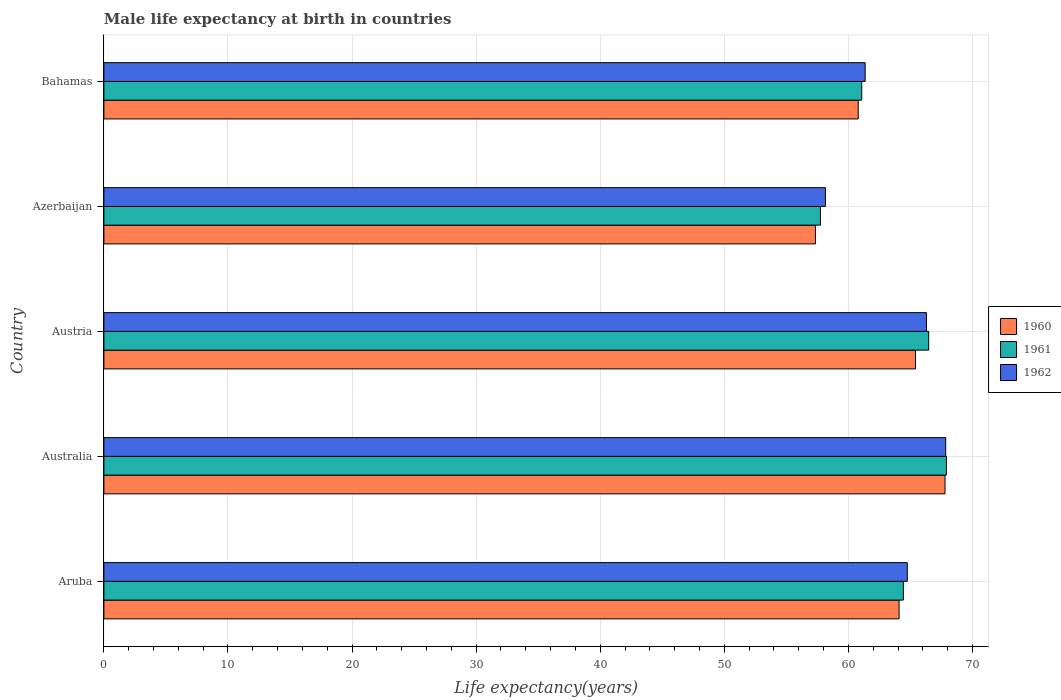How many different coloured bars are there?
Make the answer very short. 3. Are the number of bars on each tick of the Y-axis equal?
Provide a succinct answer. Yes. How many bars are there on the 2nd tick from the top?
Your response must be concise. 3. How many bars are there on the 3rd tick from the bottom?
Provide a succinct answer. 3. What is the label of the 1st group of bars from the top?
Make the answer very short. Bahamas. What is the male life expectancy at birth in 1962 in Australia?
Give a very brief answer. 67.84. Across all countries, what is the maximum male life expectancy at birth in 1961?
Provide a short and direct response. 67.9. Across all countries, what is the minimum male life expectancy at birth in 1962?
Keep it short and to the point. 58.15. In which country was the male life expectancy at birth in 1960 maximum?
Provide a succinct answer. Australia. In which country was the male life expectancy at birth in 1960 minimum?
Provide a short and direct response. Azerbaijan. What is the total male life expectancy at birth in 1962 in the graph?
Your response must be concise. 318.37. What is the difference between the male life expectancy at birth in 1962 in Australia and that in Azerbaijan?
Keep it short and to the point. 9.69. What is the difference between the male life expectancy at birth in 1962 in Bahamas and the male life expectancy at birth in 1960 in Aruba?
Ensure brevity in your answer.  -2.74. What is the average male life expectancy at birth in 1962 per country?
Offer a very short reply. 63.67. What is the difference between the male life expectancy at birth in 1962 and male life expectancy at birth in 1961 in Azerbaijan?
Provide a short and direct response. 0.4. In how many countries, is the male life expectancy at birth in 1962 greater than 62 years?
Your response must be concise. 3. What is the ratio of the male life expectancy at birth in 1962 in Australia to that in Bahamas?
Provide a short and direct response. 1.11. What is the difference between the highest and the second highest male life expectancy at birth in 1961?
Provide a succinct answer. 1.43. What is the difference between the highest and the lowest male life expectancy at birth in 1960?
Offer a terse response. 10.44. In how many countries, is the male life expectancy at birth in 1960 greater than the average male life expectancy at birth in 1960 taken over all countries?
Keep it short and to the point. 3. What does the 3rd bar from the bottom in Bahamas represents?
Give a very brief answer. 1962. Is it the case that in every country, the sum of the male life expectancy at birth in 1962 and male life expectancy at birth in 1961 is greater than the male life expectancy at birth in 1960?
Your answer should be very brief. Yes. How many bars are there?
Your response must be concise. 15. How many countries are there in the graph?
Your answer should be very brief. 5. What is the difference between two consecutive major ticks on the X-axis?
Make the answer very short. 10. Does the graph contain grids?
Ensure brevity in your answer.  Yes. How are the legend labels stacked?
Ensure brevity in your answer.  Vertical. What is the title of the graph?
Make the answer very short. Male life expectancy at birth in countries. Does "1990" appear as one of the legend labels in the graph?
Provide a short and direct response. No. What is the label or title of the X-axis?
Offer a terse response. Life expectancy(years). What is the Life expectancy(years) in 1960 in Aruba?
Make the answer very short. 64.08. What is the Life expectancy(years) in 1961 in Aruba?
Offer a terse response. 64.43. What is the Life expectancy(years) of 1962 in Aruba?
Offer a terse response. 64.75. What is the Life expectancy(years) of 1960 in Australia?
Keep it short and to the point. 67.79. What is the Life expectancy(years) in 1961 in Australia?
Provide a succinct answer. 67.9. What is the Life expectancy(years) of 1962 in Australia?
Provide a succinct answer. 67.84. What is the Life expectancy(years) of 1960 in Austria?
Your response must be concise. 65.41. What is the Life expectancy(years) in 1961 in Austria?
Your response must be concise. 66.47. What is the Life expectancy(years) in 1962 in Austria?
Your answer should be compact. 66.29. What is the Life expectancy(years) in 1960 in Azerbaijan?
Provide a succinct answer. 57.35. What is the Life expectancy(years) of 1961 in Azerbaijan?
Make the answer very short. 57.75. What is the Life expectancy(years) in 1962 in Azerbaijan?
Provide a succinct answer. 58.15. What is the Life expectancy(years) of 1960 in Bahamas?
Ensure brevity in your answer.  60.79. What is the Life expectancy(years) of 1961 in Bahamas?
Provide a succinct answer. 61.07. What is the Life expectancy(years) in 1962 in Bahamas?
Offer a very short reply. 61.35. Across all countries, what is the maximum Life expectancy(years) in 1960?
Offer a terse response. 67.79. Across all countries, what is the maximum Life expectancy(years) in 1961?
Your response must be concise. 67.9. Across all countries, what is the maximum Life expectancy(years) of 1962?
Your answer should be compact. 67.84. Across all countries, what is the minimum Life expectancy(years) of 1960?
Offer a very short reply. 57.35. Across all countries, what is the minimum Life expectancy(years) in 1961?
Provide a succinct answer. 57.75. Across all countries, what is the minimum Life expectancy(years) of 1962?
Give a very brief answer. 58.15. What is the total Life expectancy(years) of 1960 in the graph?
Your answer should be compact. 315.42. What is the total Life expectancy(years) of 1961 in the graph?
Your answer should be very brief. 317.62. What is the total Life expectancy(years) in 1962 in the graph?
Offer a very short reply. 318.37. What is the difference between the Life expectancy(years) in 1960 in Aruba and that in Australia?
Give a very brief answer. -3.7. What is the difference between the Life expectancy(years) in 1961 in Aruba and that in Australia?
Your response must be concise. -3.47. What is the difference between the Life expectancy(years) in 1962 in Aruba and that in Australia?
Your answer should be compact. -3.09. What is the difference between the Life expectancy(years) in 1960 in Aruba and that in Austria?
Your response must be concise. -1.33. What is the difference between the Life expectancy(years) of 1961 in Aruba and that in Austria?
Provide a succinct answer. -2.04. What is the difference between the Life expectancy(years) in 1962 in Aruba and that in Austria?
Give a very brief answer. -1.54. What is the difference between the Life expectancy(years) in 1960 in Aruba and that in Azerbaijan?
Provide a succinct answer. 6.74. What is the difference between the Life expectancy(years) in 1961 in Aruba and that in Azerbaijan?
Offer a very short reply. 6.68. What is the difference between the Life expectancy(years) of 1962 in Aruba and that in Azerbaijan?
Make the answer very short. 6.6. What is the difference between the Life expectancy(years) of 1960 in Aruba and that in Bahamas?
Ensure brevity in your answer.  3.29. What is the difference between the Life expectancy(years) in 1961 in Aruba and that in Bahamas?
Ensure brevity in your answer.  3.36. What is the difference between the Life expectancy(years) in 1962 in Aruba and that in Bahamas?
Keep it short and to the point. 3.4. What is the difference between the Life expectancy(years) of 1960 in Australia and that in Austria?
Offer a terse response. 2.38. What is the difference between the Life expectancy(years) of 1961 in Australia and that in Austria?
Give a very brief answer. 1.43. What is the difference between the Life expectancy(years) in 1962 in Australia and that in Austria?
Your response must be concise. 1.55. What is the difference between the Life expectancy(years) of 1960 in Australia and that in Azerbaijan?
Provide a short and direct response. 10.44. What is the difference between the Life expectancy(years) of 1961 in Australia and that in Azerbaijan?
Your answer should be very brief. 10.15. What is the difference between the Life expectancy(years) of 1962 in Australia and that in Azerbaijan?
Ensure brevity in your answer.  9.69. What is the difference between the Life expectancy(years) in 1960 in Australia and that in Bahamas?
Provide a succinct answer. 6.99. What is the difference between the Life expectancy(years) of 1961 in Australia and that in Bahamas?
Offer a terse response. 6.83. What is the difference between the Life expectancy(years) in 1962 in Australia and that in Bahamas?
Make the answer very short. 6.49. What is the difference between the Life expectancy(years) in 1960 in Austria and that in Azerbaijan?
Provide a short and direct response. 8.06. What is the difference between the Life expectancy(years) of 1961 in Austria and that in Azerbaijan?
Give a very brief answer. 8.72. What is the difference between the Life expectancy(years) in 1962 in Austria and that in Azerbaijan?
Make the answer very short. 8.14. What is the difference between the Life expectancy(years) of 1960 in Austria and that in Bahamas?
Give a very brief answer. 4.62. What is the difference between the Life expectancy(years) of 1961 in Austria and that in Bahamas?
Your answer should be very brief. 5.4. What is the difference between the Life expectancy(years) of 1962 in Austria and that in Bahamas?
Provide a short and direct response. 4.94. What is the difference between the Life expectancy(years) of 1960 in Azerbaijan and that in Bahamas?
Give a very brief answer. -3.44. What is the difference between the Life expectancy(years) in 1961 in Azerbaijan and that in Bahamas?
Make the answer very short. -3.33. What is the difference between the Life expectancy(years) in 1962 in Azerbaijan and that in Bahamas?
Give a very brief answer. -3.2. What is the difference between the Life expectancy(years) in 1960 in Aruba and the Life expectancy(years) in 1961 in Australia?
Keep it short and to the point. -3.82. What is the difference between the Life expectancy(years) of 1960 in Aruba and the Life expectancy(years) of 1962 in Australia?
Offer a terse response. -3.76. What is the difference between the Life expectancy(years) of 1961 in Aruba and the Life expectancy(years) of 1962 in Australia?
Keep it short and to the point. -3.41. What is the difference between the Life expectancy(years) of 1960 in Aruba and the Life expectancy(years) of 1961 in Austria?
Offer a very short reply. -2.39. What is the difference between the Life expectancy(years) in 1960 in Aruba and the Life expectancy(years) in 1962 in Austria?
Keep it short and to the point. -2.21. What is the difference between the Life expectancy(years) of 1961 in Aruba and the Life expectancy(years) of 1962 in Austria?
Offer a terse response. -1.86. What is the difference between the Life expectancy(years) in 1960 in Aruba and the Life expectancy(years) in 1961 in Azerbaijan?
Offer a terse response. 6.34. What is the difference between the Life expectancy(years) in 1960 in Aruba and the Life expectancy(years) in 1962 in Azerbaijan?
Your answer should be very brief. 5.94. What is the difference between the Life expectancy(years) in 1961 in Aruba and the Life expectancy(years) in 1962 in Azerbaijan?
Provide a short and direct response. 6.28. What is the difference between the Life expectancy(years) of 1960 in Aruba and the Life expectancy(years) of 1961 in Bahamas?
Offer a very short reply. 3.01. What is the difference between the Life expectancy(years) of 1960 in Aruba and the Life expectancy(years) of 1962 in Bahamas?
Your answer should be very brief. 2.73. What is the difference between the Life expectancy(years) of 1961 in Aruba and the Life expectancy(years) of 1962 in Bahamas?
Provide a short and direct response. 3.08. What is the difference between the Life expectancy(years) in 1960 in Australia and the Life expectancy(years) in 1961 in Austria?
Your answer should be very brief. 1.32. What is the difference between the Life expectancy(years) in 1960 in Australia and the Life expectancy(years) in 1962 in Austria?
Ensure brevity in your answer.  1.5. What is the difference between the Life expectancy(years) in 1961 in Australia and the Life expectancy(years) in 1962 in Austria?
Provide a short and direct response. 1.61. What is the difference between the Life expectancy(years) in 1960 in Australia and the Life expectancy(years) in 1961 in Azerbaijan?
Your answer should be compact. 10.04. What is the difference between the Life expectancy(years) in 1960 in Australia and the Life expectancy(years) in 1962 in Azerbaijan?
Make the answer very short. 9.64. What is the difference between the Life expectancy(years) in 1961 in Australia and the Life expectancy(years) in 1962 in Azerbaijan?
Give a very brief answer. 9.75. What is the difference between the Life expectancy(years) of 1960 in Australia and the Life expectancy(years) of 1961 in Bahamas?
Your response must be concise. 6.71. What is the difference between the Life expectancy(years) of 1960 in Australia and the Life expectancy(years) of 1962 in Bahamas?
Provide a short and direct response. 6.44. What is the difference between the Life expectancy(years) of 1961 in Australia and the Life expectancy(years) of 1962 in Bahamas?
Your answer should be very brief. 6.55. What is the difference between the Life expectancy(years) in 1960 in Austria and the Life expectancy(years) in 1961 in Azerbaijan?
Your answer should be compact. 7.66. What is the difference between the Life expectancy(years) in 1960 in Austria and the Life expectancy(years) in 1962 in Azerbaijan?
Your answer should be compact. 7.26. What is the difference between the Life expectancy(years) in 1961 in Austria and the Life expectancy(years) in 1962 in Azerbaijan?
Your answer should be compact. 8.32. What is the difference between the Life expectancy(years) of 1960 in Austria and the Life expectancy(years) of 1961 in Bahamas?
Offer a terse response. 4.34. What is the difference between the Life expectancy(years) of 1960 in Austria and the Life expectancy(years) of 1962 in Bahamas?
Provide a succinct answer. 4.06. What is the difference between the Life expectancy(years) in 1961 in Austria and the Life expectancy(years) in 1962 in Bahamas?
Keep it short and to the point. 5.12. What is the difference between the Life expectancy(years) in 1960 in Azerbaijan and the Life expectancy(years) in 1961 in Bahamas?
Provide a short and direct response. -3.73. What is the difference between the Life expectancy(years) in 1960 in Azerbaijan and the Life expectancy(years) in 1962 in Bahamas?
Your answer should be compact. -4. What is the difference between the Life expectancy(years) in 1961 in Azerbaijan and the Life expectancy(years) in 1962 in Bahamas?
Keep it short and to the point. -3.6. What is the average Life expectancy(years) of 1960 per country?
Your answer should be very brief. 63.08. What is the average Life expectancy(years) in 1961 per country?
Your answer should be compact. 63.52. What is the average Life expectancy(years) in 1962 per country?
Provide a short and direct response. 63.67. What is the difference between the Life expectancy(years) in 1960 and Life expectancy(years) in 1961 in Aruba?
Keep it short and to the point. -0.34. What is the difference between the Life expectancy(years) in 1960 and Life expectancy(years) in 1962 in Aruba?
Ensure brevity in your answer.  -0.66. What is the difference between the Life expectancy(years) in 1961 and Life expectancy(years) in 1962 in Aruba?
Provide a succinct answer. -0.32. What is the difference between the Life expectancy(years) in 1960 and Life expectancy(years) in 1961 in Australia?
Give a very brief answer. -0.11. What is the difference between the Life expectancy(years) in 1960 and Life expectancy(years) in 1962 in Australia?
Ensure brevity in your answer.  -0.05. What is the difference between the Life expectancy(years) in 1960 and Life expectancy(years) in 1961 in Austria?
Your answer should be compact. -1.06. What is the difference between the Life expectancy(years) in 1960 and Life expectancy(years) in 1962 in Austria?
Your answer should be compact. -0.88. What is the difference between the Life expectancy(years) of 1961 and Life expectancy(years) of 1962 in Austria?
Keep it short and to the point. 0.18. What is the difference between the Life expectancy(years) of 1960 and Life expectancy(years) of 1961 in Azerbaijan?
Your response must be concise. -0.4. What is the difference between the Life expectancy(years) in 1960 and Life expectancy(years) in 1962 in Azerbaijan?
Offer a terse response. -0.8. What is the difference between the Life expectancy(years) of 1961 and Life expectancy(years) of 1962 in Azerbaijan?
Ensure brevity in your answer.  -0.4. What is the difference between the Life expectancy(years) in 1960 and Life expectancy(years) in 1961 in Bahamas?
Keep it short and to the point. -0.28. What is the difference between the Life expectancy(years) of 1960 and Life expectancy(years) of 1962 in Bahamas?
Make the answer very short. -0.56. What is the difference between the Life expectancy(years) of 1961 and Life expectancy(years) of 1962 in Bahamas?
Keep it short and to the point. -0.28. What is the ratio of the Life expectancy(years) in 1960 in Aruba to that in Australia?
Provide a succinct answer. 0.95. What is the ratio of the Life expectancy(years) of 1961 in Aruba to that in Australia?
Offer a terse response. 0.95. What is the ratio of the Life expectancy(years) of 1962 in Aruba to that in Australia?
Ensure brevity in your answer.  0.95. What is the ratio of the Life expectancy(years) of 1960 in Aruba to that in Austria?
Provide a short and direct response. 0.98. What is the ratio of the Life expectancy(years) in 1961 in Aruba to that in Austria?
Offer a very short reply. 0.97. What is the ratio of the Life expectancy(years) in 1962 in Aruba to that in Austria?
Give a very brief answer. 0.98. What is the ratio of the Life expectancy(years) of 1960 in Aruba to that in Azerbaijan?
Give a very brief answer. 1.12. What is the ratio of the Life expectancy(years) in 1961 in Aruba to that in Azerbaijan?
Offer a terse response. 1.12. What is the ratio of the Life expectancy(years) in 1962 in Aruba to that in Azerbaijan?
Make the answer very short. 1.11. What is the ratio of the Life expectancy(years) in 1960 in Aruba to that in Bahamas?
Ensure brevity in your answer.  1.05. What is the ratio of the Life expectancy(years) in 1961 in Aruba to that in Bahamas?
Your response must be concise. 1.05. What is the ratio of the Life expectancy(years) in 1962 in Aruba to that in Bahamas?
Keep it short and to the point. 1.06. What is the ratio of the Life expectancy(years) in 1960 in Australia to that in Austria?
Give a very brief answer. 1.04. What is the ratio of the Life expectancy(years) in 1961 in Australia to that in Austria?
Offer a very short reply. 1.02. What is the ratio of the Life expectancy(years) of 1962 in Australia to that in Austria?
Keep it short and to the point. 1.02. What is the ratio of the Life expectancy(years) of 1960 in Australia to that in Azerbaijan?
Your response must be concise. 1.18. What is the ratio of the Life expectancy(years) of 1961 in Australia to that in Azerbaijan?
Keep it short and to the point. 1.18. What is the ratio of the Life expectancy(years) in 1960 in Australia to that in Bahamas?
Provide a short and direct response. 1.12. What is the ratio of the Life expectancy(years) in 1961 in Australia to that in Bahamas?
Ensure brevity in your answer.  1.11. What is the ratio of the Life expectancy(years) of 1962 in Australia to that in Bahamas?
Offer a very short reply. 1.11. What is the ratio of the Life expectancy(years) of 1960 in Austria to that in Azerbaijan?
Provide a succinct answer. 1.14. What is the ratio of the Life expectancy(years) in 1961 in Austria to that in Azerbaijan?
Offer a very short reply. 1.15. What is the ratio of the Life expectancy(years) of 1962 in Austria to that in Azerbaijan?
Make the answer very short. 1.14. What is the ratio of the Life expectancy(years) in 1960 in Austria to that in Bahamas?
Ensure brevity in your answer.  1.08. What is the ratio of the Life expectancy(years) of 1961 in Austria to that in Bahamas?
Your answer should be compact. 1.09. What is the ratio of the Life expectancy(years) of 1962 in Austria to that in Bahamas?
Give a very brief answer. 1.08. What is the ratio of the Life expectancy(years) in 1960 in Azerbaijan to that in Bahamas?
Your answer should be very brief. 0.94. What is the ratio of the Life expectancy(years) in 1961 in Azerbaijan to that in Bahamas?
Your response must be concise. 0.95. What is the ratio of the Life expectancy(years) of 1962 in Azerbaijan to that in Bahamas?
Ensure brevity in your answer.  0.95. What is the difference between the highest and the second highest Life expectancy(years) of 1960?
Provide a short and direct response. 2.38. What is the difference between the highest and the second highest Life expectancy(years) in 1961?
Offer a terse response. 1.43. What is the difference between the highest and the second highest Life expectancy(years) in 1962?
Give a very brief answer. 1.55. What is the difference between the highest and the lowest Life expectancy(years) in 1960?
Ensure brevity in your answer.  10.44. What is the difference between the highest and the lowest Life expectancy(years) of 1961?
Your answer should be compact. 10.15. What is the difference between the highest and the lowest Life expectancy(years) of 1962?
Make the answer very short. 9.69. 